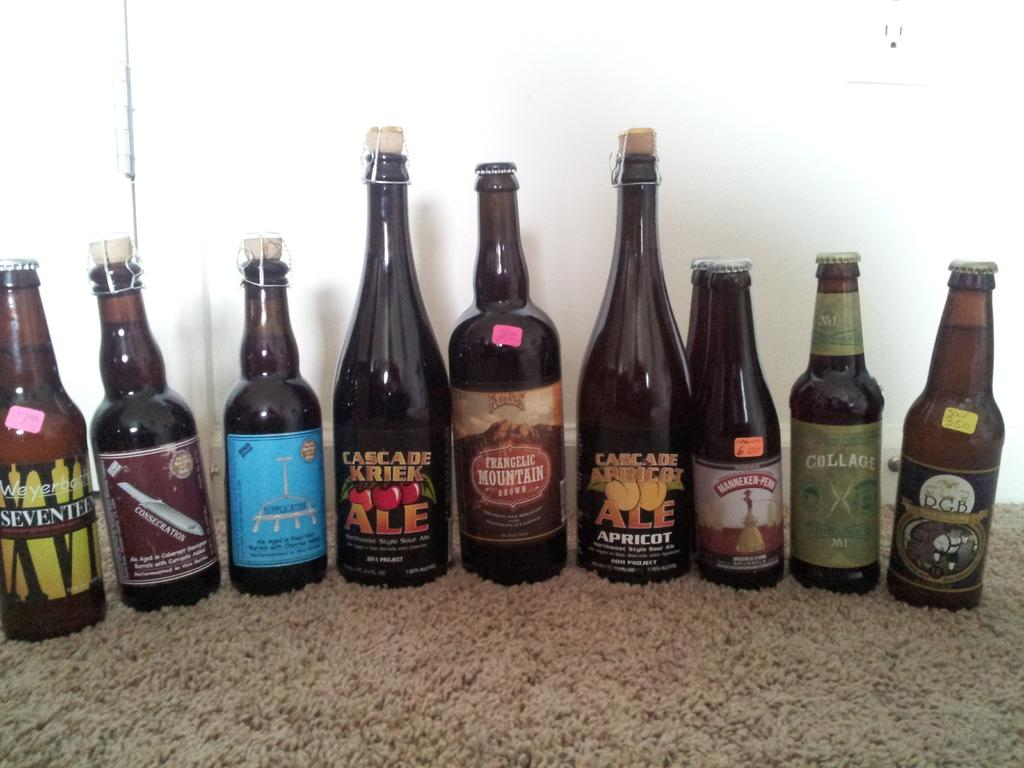What type of beverage containers are visible in the image? There are wine bottles in the image. Where are the wine bottles located? The wine bottles are on a carpet. What can be seen in the background of the image? There is a wall in the background of the image. How many houses can be seen in the image? There are no houses visible in the image; it features wine bottles on a carpet with a wall in the background. What type of baby is present in the image? There is no baby present in the image. 